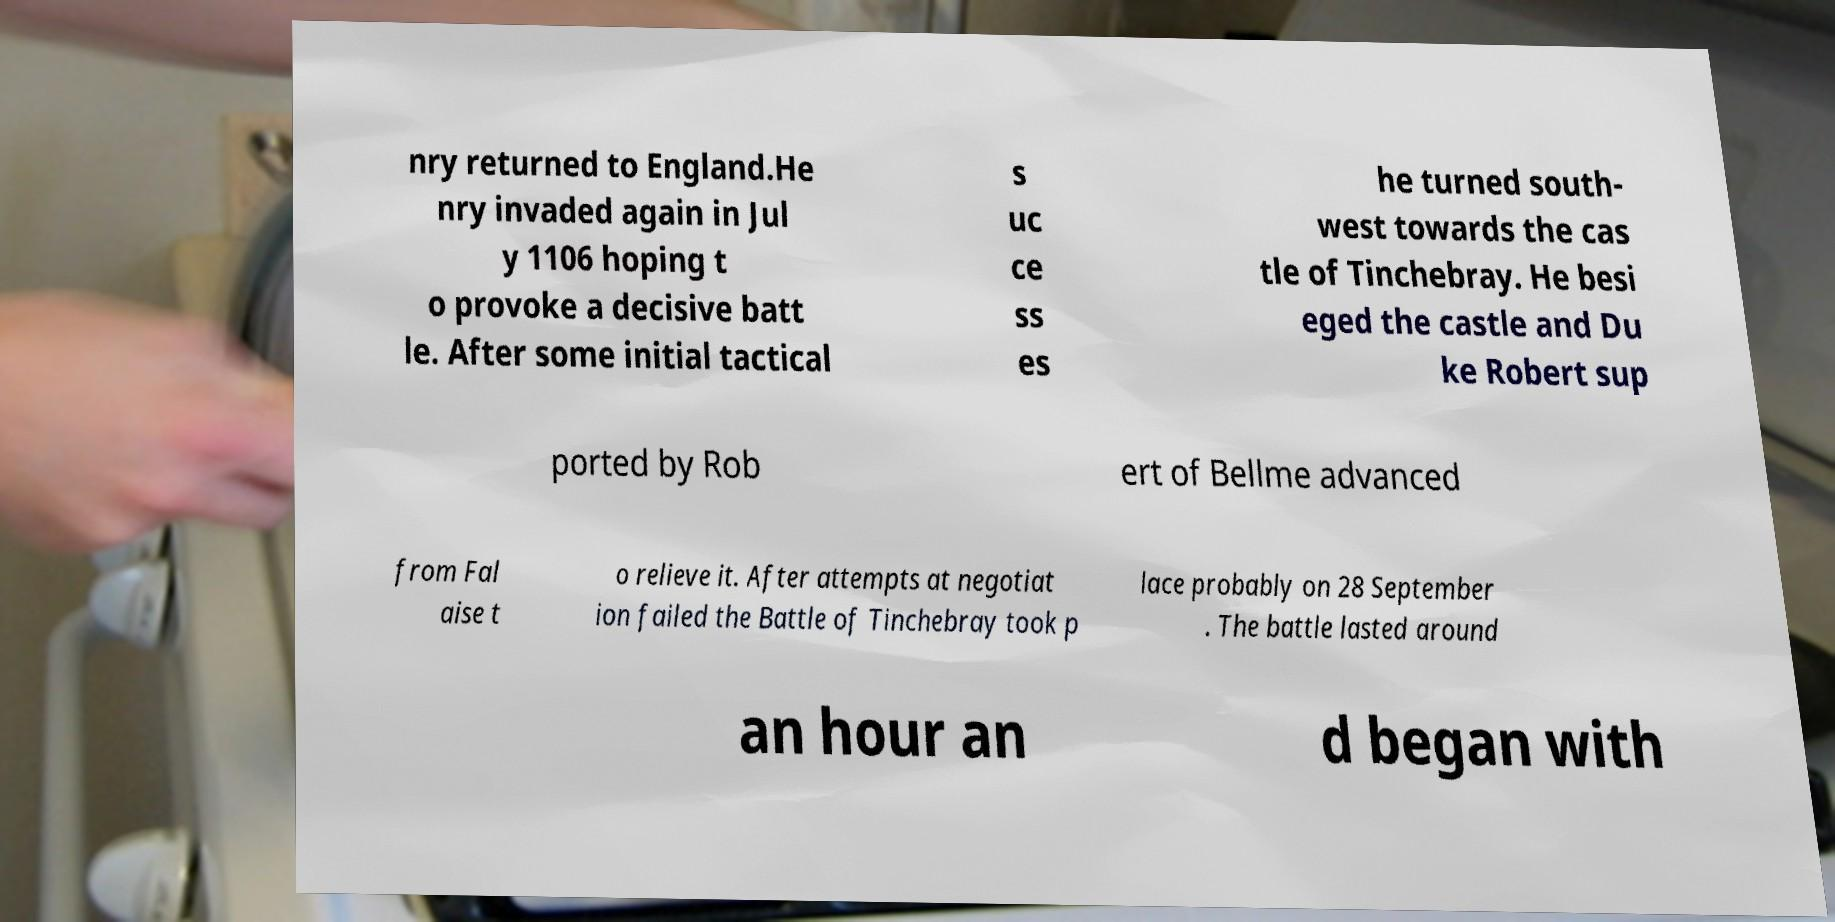What messages or text are displayed in this image? I need them in a readable, typed format. nry returned to England.He nry invaded again in Jul y 1106 hoping t o provoke a decisive batt le. After some initial tactical s uc ce ss es he turned south- west towards the cas tle of Tinchebray. He besi eged the castle and Du ke Robert sup ported by Rob ert of Bellme advanced from Fal aise t o relieve it. After attempts at negotiat ion failed the Battle of Tinchebray took p lace probably on 28 September . The battle lasted around an hour an d began with 